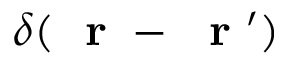Convert formula to latex. <formula><loc_0><loc_0><loc_500><loc_500>\delta ( r - r ^ { \prime } )</formula> 